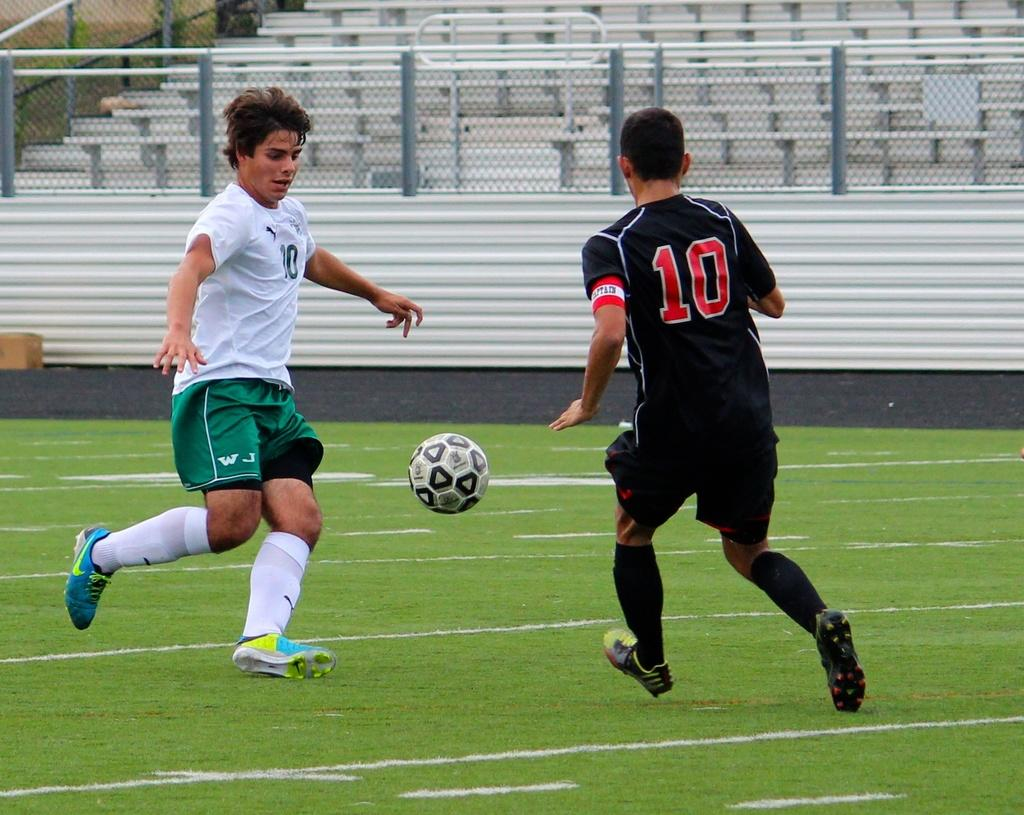Provide a one-sentence caption for the provided image. Player number 10 in a black uniform is going for the soccer ball. 